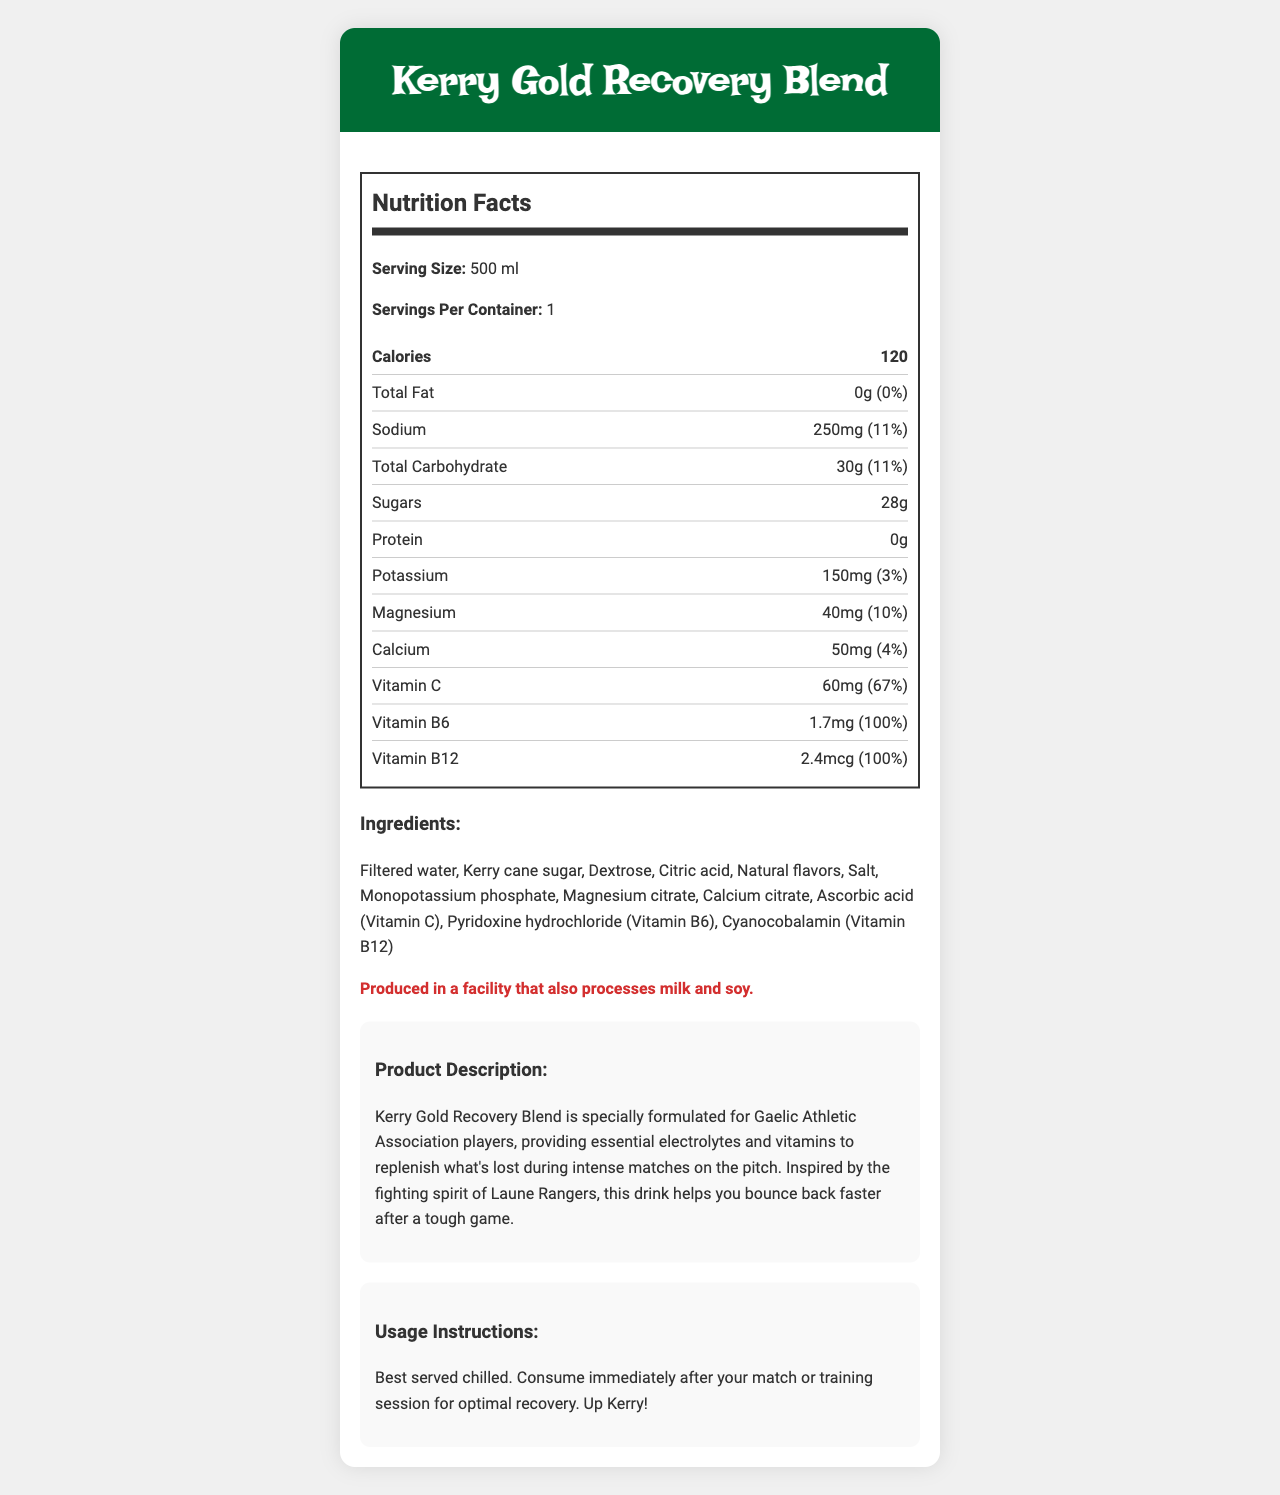what is the serving size for "Kerry Gold Recovery Blend"? The serving size is explicitly mentioned as "500 ml" in the nutrition facts section of the document.
Answer: 500 ml how many calories are in one serving of the drink? The document indicates that there are 120 calories per serving.
Answer: 120 what is the percentage of daily value of sodium in one serving? The nutrition facts label shows that the daily value percentage for sodium is 11%.
Answer: 11% is there any protein in the "Kerry Gold Recovery Blend"? The nutrition facts label lists the amount of protein as 0g, meaning there is no protein in the drink.
Answer: No what is the primary source of sweetness in the "Kerry Gold Recovery Blend"? The ingredients list includes "Kerry cane sugar" and "Dextrose", with "Kerry cane sugar" being a primary source of sweetness.
Answer: Kerry cane sugar how much vitamin C is in each serving? The vitamin C content per serving is 60 mg, as shown in the nutrition facts.
Answer: 60mg how many ingredients are listed in the "Kerry Gold Recovery Blend"? By counting all the items in the ingredients list, we see there are 12 ingredients.
Answer: 12 what is the percentage of daily value for vitamin B6 in one serving? The daily value percentage for vitamin B6 is 100%, as indicated in the nutrition facts.
Answer: 100% how should the "Kerry Gold Recovery Blend" be consumed for optimal recovery? The usage instructions section clearly mentions these details.
Answer: Best served chilled. Consume immediately after your match or training session for optimal recovery. which of the following vitamins is found in the highest daily value percentage in one serving? A. Vitamin C B. Vitamin B6 C. Vitamin B12 D. All of the above The daily value percentages for both Vitamin B6 and Vitamin B12 are 100%, and Vitamin C is 67%. Therefore, B6 and B12 have the highest, but all are significant.
Answer: D. All of the above how much potassium does the "Kerry Gold Recovery Blend" contain? A. 100mg B. 120mg C. 150mg D. 200mg The nutrition facts label indicates that the drink contains 150mg of potassium.
Answer: C. 150mg does the drink contain any calcium? The nutrition facts label shows that the drink contains 50mg of calcium (4% daily value).
Answer: Yes what is the drink specially formulated for? The product description states that it is specially formulated for Gaelic Athletic Association players.
Answer: Gaelic Athletic Association players summarize the main idea of the document. The document provides detailed nutritional information, ingredients, usage instructions, and a description of the product aimed at helping athletes recover post-match.
Answer: "Kerry Gold Recovery Blend" is a post-match recovery drink designed for Gaelic Athletic Association players. It provides essential electrolytes and vitamins to aid in recovery after intense matches. The drink contains no fat or protein, has a notable amount of sugars and carbohydrates, and includes key minerals like sodium, potassium, magnesium, and calcium. Vitamins C, B6, and B12 are also significant components. The product is best consumed chilled immediately after a match or training session for optimal recovery. what is the sugar content percentage of the drink? The document lists the sugar content as 28g but does not provide a daily value percentage for sugars.
Answer: Not enough information 